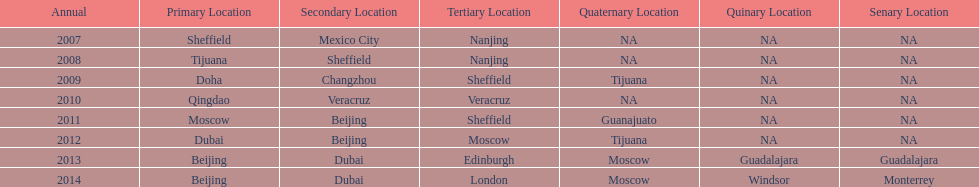Name a year whose second venue was the same as 2011. 2012. 